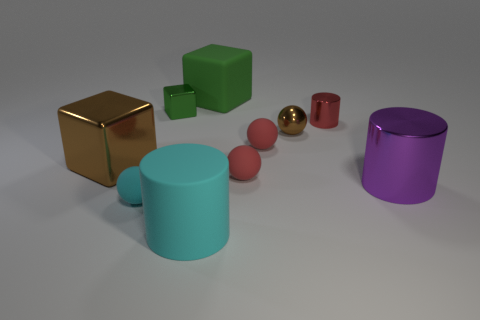What materials do the objects in the image appear to be made of? The objects displayed here show a variety of textures and reflections that suggest they are made from different materials. The shiny golden cube suggests a polished metallic surface, possibly gold or a gold-like material. The dark brown cube appears glossy, which could suggest a polished wood or a wood-like finish. Similarly, the matte finish on the green and red objects hints at a rubbery material. The purple and turquoise cylinders, with their slightly reflective surfaces, could suggest a plastic material. 